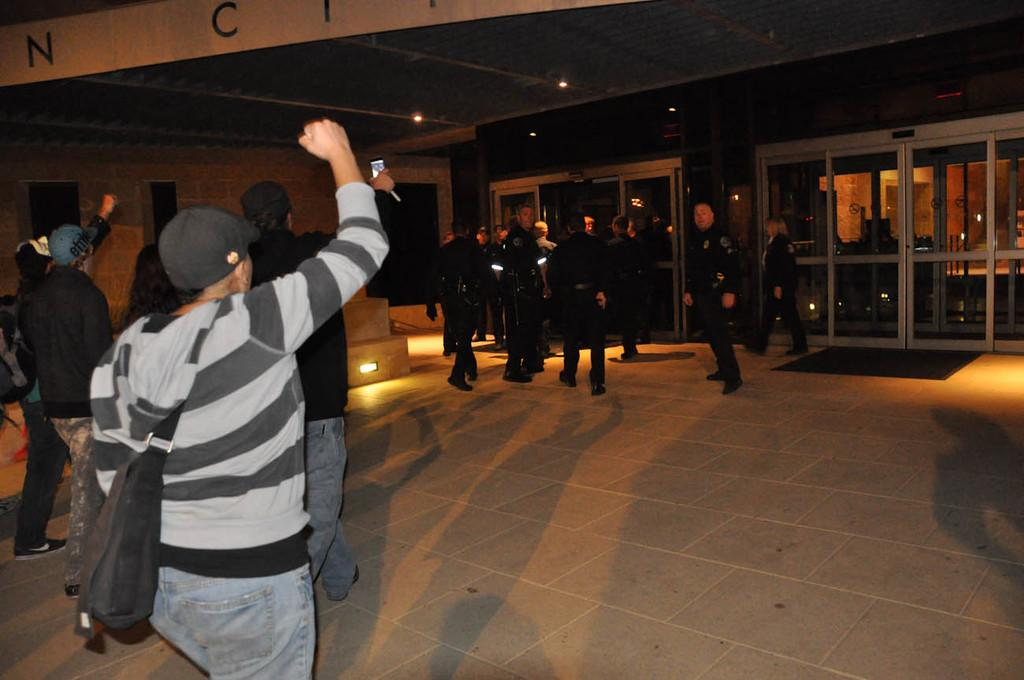What are the people in the image doing? The people in the image are walking. Can you describe the gender of the majority of the people in the image? Most of the people in the image are men. What type of surface can be seen under the people's feet? There is a floor visible in the image. What architectural feature can be seen in the background of the image? There are glass doors in the background of the image. What type of flower is being stamped on the glass doors in the image? There is no flower or stamping visible on the glass doors in the image. 